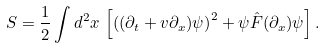<formula> <loc_0><loc_0><loc_500><loc_500>S = \frac { 1 } { 2 } \int d ^ { 2 } x \, \left [ \left ( ( \partial _ { t } + v \partial _ { x } ) \psi \right ) ^ { 2 } + \psi { \hat { F } } ( \partial _ { x } ) \psi \right ] .</formula> 